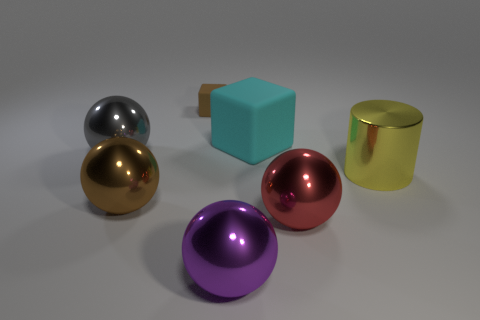Subtract all red balls. How many balls are left? 3 Subtract all gray spheres. How many spheres are left? 3 Subtract all cyan balls. Subtract all red cylinders. How many balls are left? 4 Add 1 large gray spheres. How many objects exist? 8 Subtract all cylinders. How many objects are left? 6 Subtract 0 cyan cylinders. How many objects are left? 7 Subtract all big blocks. Subtract all brown metallic things. How many objects are left? 5 Add 4 big gray balls. How many big gray balls are left? 5 Add 3 tiny blue balls. How many tiny blue balls exist? 3 